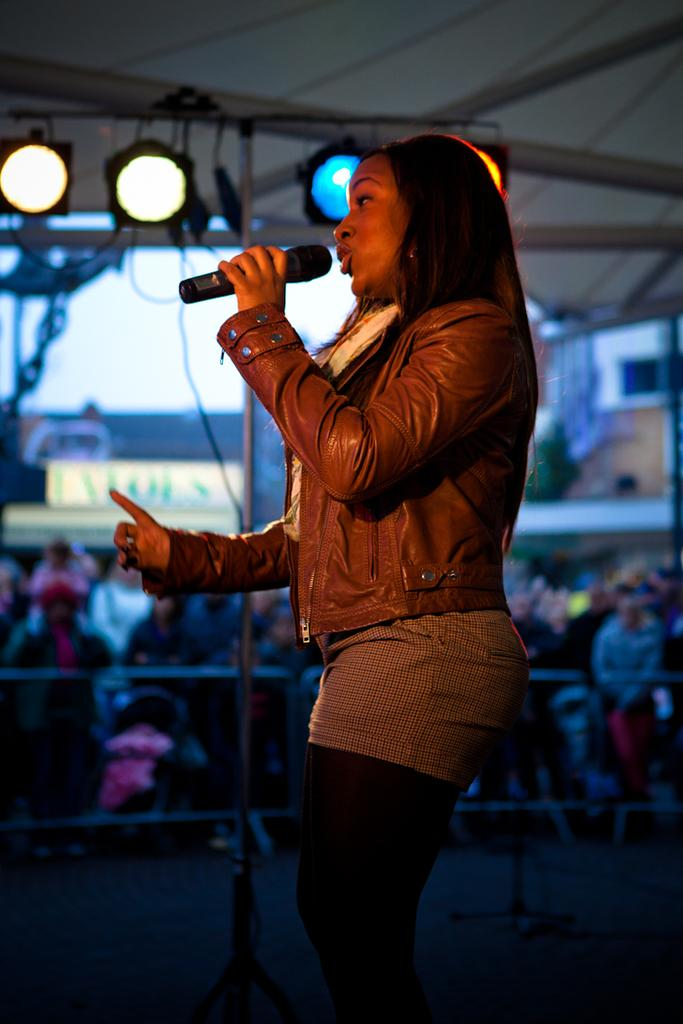What is the main activity taking place on the stage in the image? There is a person singing on the stage in the image. What is the person holding while singing? The person is holding a microphone. Who is present in the area surrounding the stage? There are people in the audience. How would you describe the weather based on the image? The background appears to be sunny. What type of comb is the person using to style their hair while singing on stage? There is no comb visible in the image, and the person's hair is not being styled during the performance. How many heads of lettuce can be seen in the audience? There are no heads of lettuce present in the image; the audience is composed of people. 